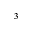<formula> <loc_0><loc_0><loc_500><loc_500>^ { 3 }</formula> 